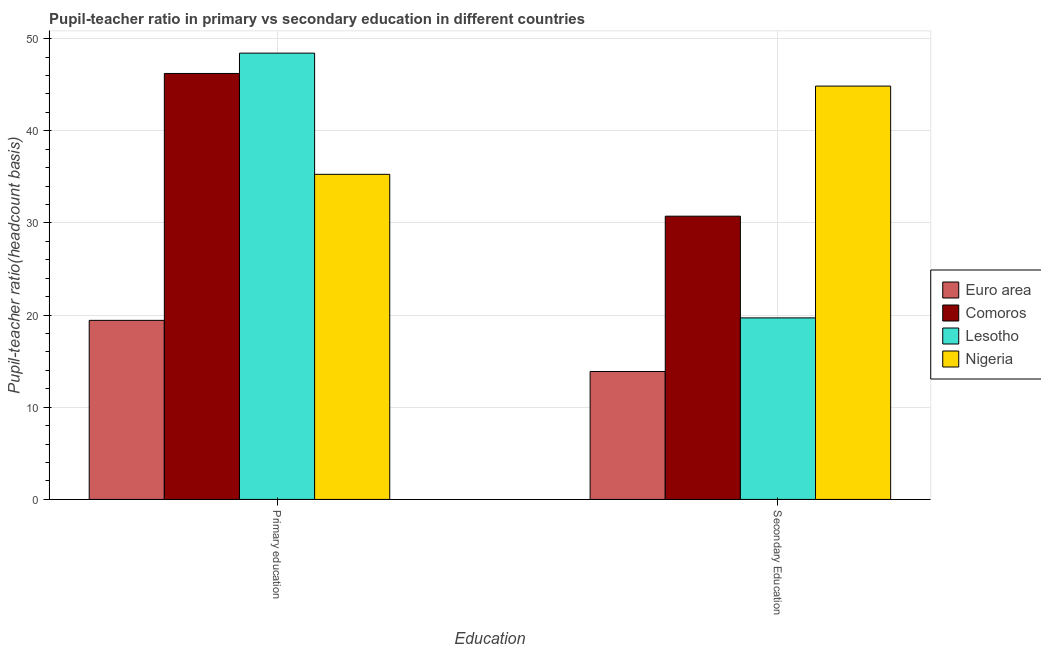Are the number of bars per tick equal to the number of legend labels?
Offer a terse response. Yes. Are the number of bars on each tick of the X-axis equal?
Keep it short and to the point. Yes. What is the label of the 1st group of bars from the left?
Keep it short and to the point. Primary education. What is the pupil teacher ratio on secondary education in Lesotho?
Your answer should be very brief. 19.7. Across all countries, what is the maximum pupil-teacher ratio in primary education?
Make the answer very short. 48.42. Across all countries, what is the minimum pupil teacher ratio on secondary education?
Make the answer very short. 13.88. In which country was the pupil-teacher ratio in primary education maximum?
Provide a short and direct response. Lesotho. In which country was the pupil-teacher ratio in primary education minimum?
Provide a short and direct response. Euro area. What is the total pupil teacher ratio on secondary education in the graph?
Make the answer very short. 109.15. What is the difference between the pupil teacher ratio on secondary education in Nigeria and that in Euro area?
Ensure brevity in your answer.  30.96. What is the difference between the pupil-teacher ratio in primary education in Euro area and the pupil teacher ratio on secondary education in Comoros?
Keep it short and to the point. -11.3. What is the average pupil teacher ratio on secondary education per country?
Offer a terse response. 27.29. What is the difference between the pupil-teacher ratio in primary education and pupil teacher ratio on secondary education in Euro area?
Provide a short and direct response. 5.55. In how many countries, is the pupil teacher ratio on secondary education greater than 14 ?
Provide a short and direct response. 3. What is the ratio of the pupil teacher ratio on secondary education in Lesotho to that in Nigeria?
Keep it short and to the point. 0.44. What does the 1st bar from the left in Secondary Education represents?
Provide a short and direct response. Euro area. What does the 2nd bar from the right in Primary education represents?
Ensure brevity in your answer.  Lesotho. Are the values on the major ticks of Y-axis written in scientific E-notation?
Make the answer very short. No. Does the graph contain any zero values?
Your answer should be compact. No. How are the legend labels stacked?
Keep it short and to the point. Vertical. What is the title of the graph?
Provide a short and direct response. Pupil-teacher ratio in primary vs secondary education in different countries. What is the label or title of the X-axis?
Your answer should be very brief. Education. What is the label or title of the Y-axis?
Ensure brevity in your answer.  Pupil-teacher ratio(headcount basis). What is the Pupil-teacher ratio(headcount basis) of Euro area in Primary education?
Your answer should be very brief. 19.43. What is the Pupil-teacher ratio(headcount basis) of Comoros in Primary education?
Keep it short and to the point. 46.21. What is the Pupil-teacher ratio(headcount basis) of Lesotho in Primary education?
Your answer should be very brief. 48.42. What is the Pupil-teacher ratio(headcount basis) of Nigeria in Primary education?
Provide a short and direct response. 35.27. What is the Pupil-teacher ratio(headcount basis) of Euro area in Secondary Education?
Offer a very short reply. 13.88. What is the Pupil-teacher ratio(headcount basis) of Comoros in Secondary Education?
Your response must be concise. 30.73. What is the Pupil-teacher ratio(headcount basis) in Lesotho in Secondary Education?
Your answer should be compact. 19.7. What is the Pupil-teacher ratio(headcount basis) in Nigeria in Secondary Education?
Make the answer very short. 44.85. Across all Education, what is the maximum Pupil-teacher ratio(headcount basis) of Euro area?
Your answer should be compact. 19.43. Across all Education, what is the maximum Pupil-teacher ratio(headcount basis) in Comoros?
Offer a very short reply. 46.21. Across all Education, what is the maximum Pupil-teacher ratio(headcount basis) of Lesotho?
Offer a terse response. 48.42. Across all Education, what is the maximum Pupil-teacher ratio(headcount basis) in Nigeria?
Give a very brief answer. 44.85. Across all Education, what is the minimum Pupil-teacher ratio(headcount basis) of Euro area?
Provide a short and direct response. 13.88. Across all Education, what is the minimum Pupil-teacher ratio(headcount basis) of Comoros?
Offer a very short reply. 30.73. Across all Education, what is the minimum Pupil-teacher ratio(headcount basis) of Lesotho?
Your answer should be compact. 19.7. Across all Education, what is the minimum Pupil-teacher ratio(headcount basis) of Nigeria?
Your answer should be very brief. 35.27. What is the total Pupil-teacher ratio(headcount basis) of Euro area in the graph?
Your answer should be very brief. 33.31. What is the total Pupil-teacher ratio(headcount basis) in Comoros in the graph?
Ensure brevity in your answer.  76.94. What is the total Pupil-teacher ratio(headcount basis) of Lesotho in the graph?
Your answer should be compact. 68.12. What is the total Pupil-teacher ratio(headcount basis) of Nigeria in the graph?
Give a very brief answer. 80.12. What is the difference between the Pupil-teacher ratio(headcount basis) in Euro area in Primary education and that in Secondary Education?
Your answer should be very brief. 5.55. What is the difference between the Pupil-teacher ratio(headcount basis) of Comoros in Primary education and that in Secondary Education?
Give a very brief answer. 15.48. What is the difference between the Pupil-teacher ratio(headcount basis) of Lesotho in Primary education and that in Secondary Education?
Offer a very short reply. 28.72. What is the difference between the Pupil-teacher ratio(headcount basis) of Nigeria in Primary education and that in Secondary Education?
Make the answer very short. -9.57. What is the difference between the Pupil-teacher ratio(headcount basis) in Euro area in Primary education and the Pupil-teacher ratio(headcount basis) in Comoros in Secondary Education?
Offer a terse response. -11.3. What is the difference between the Pupil-teacher ratio(headcount basis) in Euro area in Primary education and the Pupil-teacher ratio(headcount basis) in Lesotho in Secondary Education?
Keep it short and to the point. -0.27. What is the difference between the Pupil-teacher ratio(headcount basis) in Euro area in Primary education and the Pupil-teacher ratio(headcount basis) in Nigeria in Secondary Education?
Keep it short and to the point. -25.42. What is the difference between the Pupil-teacher ratio(headcount basis) of Comoros in Primary education and the Pupil-teacher ratio(headcount basis) of Lesotho in Secondary Education?
Offer a very short reply. 26.52. What is the difference between the Pupil-teacher ratio(headcount basis) in Comoros in Primary education and the Pupil-teacher ratio(headcount basis) in Nigeria in Secondary Education?
Keep it short and to the point. 1.37. What is the difference between the Pupil-teacher ratio(headcount basis) of Lesotho in Primary education and the Pupil-teacher ratio(headcount basis) of Nigeria in Secondary Education?
Offer a very short reply. 3.57. What is the average Pupil-teacher ratio(headcount basis) in Euro area per Education?
Your answer should be compact. 16.65. What is the average Pupil-teacher ratio(headcount basis) of Comoros per Education?
Ensure brevity in your answer.  38.47. What is the average Pupil-teacher ratio(headcount basis) in Lesotho per Education?
Offer a very short reply. 34.06. What is the average Pupil-teacher ratio(headcount basis) of Nigeria per Education?
Offer a terse response. 40.06. What is the difference between the Pupil-teacher ratio(headcount basis) in Euro area and Pupil-teacher ratio(headcount basis) in Comoros in Primary education?
Give a very brief answer. -26.79. What is the difference between the Pupil-teacher ratio(headcount basis) of Euro area and Pupil-teacher ratio(headcount basis) of Lesotho in Primary education?
Give a very brief answer. -28.99. What is the difference between the Pupil-teacher ratio(headcount basis) of Euro area and Pupil-teacher ratio(headcount basis) of Nigeria in Primary education?
Make the answer very short. -15.84. What is the difference between the Pupil-teacher ratio(headcount basis) in Comoros and Pupil-teacher ratio(headcount basis) in Lesotho in Primary education?
Your answer should be compact. -2.21. What is the difference between the Pupil-teacher ratio(headcount basis) of Comoros and Pupil-teacher ratio(headcount basis) of Nigeria in Primary education?
Offer a very short reply. 10.94. What is the difference between the Pupil-teacher ratio(headcount basis) of Lesotho and Pupil-teacher ratio(headcount basis) of Nigeria in Primary education?
Your answer should be very brief. 13.15. What is the difference between the Pupil-teacher ratio(headcount basis) in Euro area and Pupil-teacher ratio(headcount basis) in Comoros in Secondary Education?
Keep it short and to the point. -16.85. What is the difference between the Pupil-teacher ratio(headcount basis) of Euro area and Pupil-teacher ratio(headcount basis) of Lesotho in Secondary Education?
Your answer should be very brief. -5.82. What is the difference between the Pupil-teacher ratio(headcount basis) of Euro area and Pupil-teacher ratio(headcount basis) of Nigeria in Secondary Education?
Offer a very short reply. -30.96. What is the difference between the Pupil-teacher ratio(headcount basis) of Comoros and Pupil-teacher ratio(headcount basis) of Lesotho in Secondary Education?
Your answer should be very brief. 11.03. What is the difference between the Pupil-teacher ratio(headcount basis) in Comoros and Pupil-teacher ratio(headcount basis) in Nigeria in Secondary Education?
Give a very brief answer. -14.11. What is the difference between the Pupil-teacher ratio(headcount basis) in Lesotho and Pupil-teacher ratio(headcount basis) in Nigeria in Secondary Education?
Your response must be concise. -25.15. What is the ratio of the Pupil-teacher ratio(headcount basis) in Euro area in Primary education to that in Secondary Education?
Your response must be concise. 1.4. What is the ratio of the Pupil-teacher ratio(headcount basis) in Comoros in Primary education to that in Secondary Education?
Provide a short and direct response. 1.5. What is the ratio of the Pupil-teacher ratio(headcount basis) of Lesotho in Primary education to that in Secondary Education?
Give a very brief answer. 2.46. What is the ratio of the Pupil-teacher ratio(headcount basis) of Nigeria in Primary education to that in Secondary Education?
Your response must be concise. 0.79. What is the difference between the highest and the second highest Pupil-teacher ratio(headcount basis) in Euro area?
Give a very brief answer. 5.55. What is the difference between the highest and the second highest Pupil-teacher ratio(headcount basis) in Comoros?
Offer a very short reply. 15.48. What is the difference between the highest and the second highest Pupil-teacher ratio(headcount basis) in Lesotho?
Ensure brevity in your answer.  28.72. What is the difference between the highest and the second highest Pupil-teacher ratio(headcount basis) of Nigeria?
Make the answer very short. 9.57. What is the difference between the highest and the lowest Pupil-teacher ratio(headcount basis) of Euro area?
Make the answer very short. 5.55. What is the difference between the highest and the lowest Pupil-teacher ratio(headcount basis) in Comoros?
Make the answer very short. 15.48. What is the difference between the highest and the lowest Pupil-teacher ratio(headcount basis) in Lesotho?
Give a very brief answer. 28.72. What is the difference between the highest and the lowest Pupil-teacher ratio(headcount basis) of Nigeria?
Your answer should be compact. 9.57. 